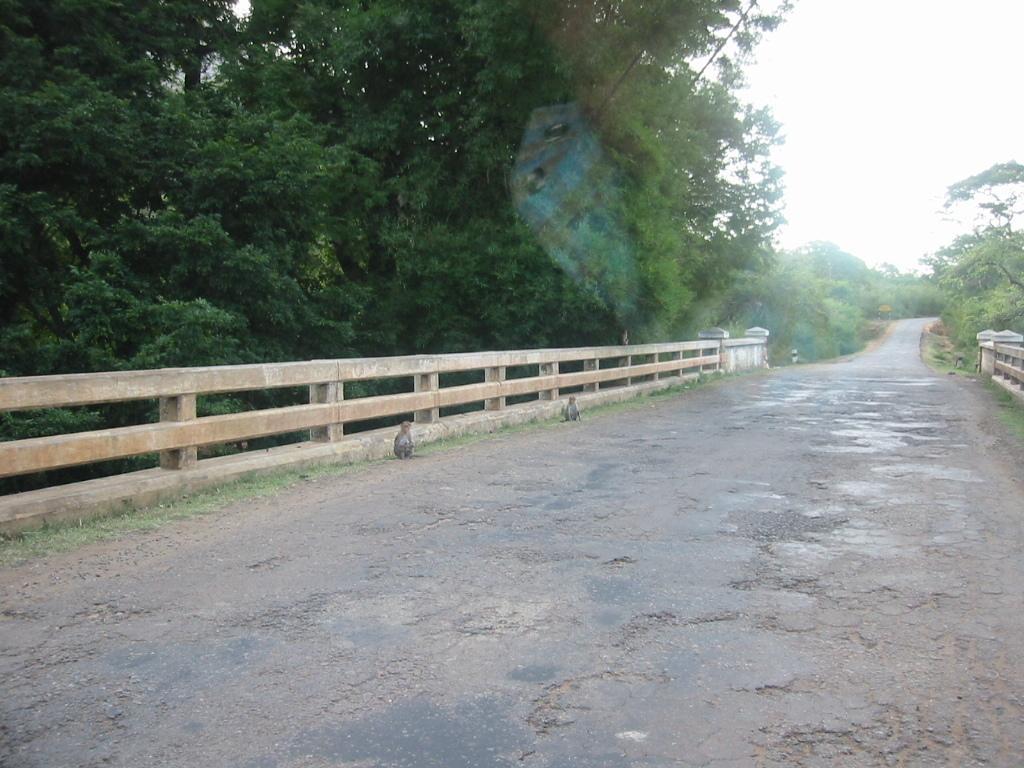Describe this image in one or two sentences. In this image we can see road, monkeys, grass, railings, and trees. In the background there is sky. 